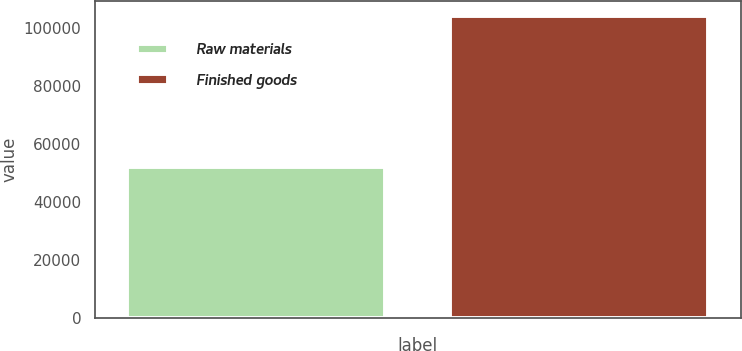Convert chart. <chart><loc_0><loc_0><loc_500><loc_500><bar_chart><fcel>Raw materials<fcel>Finished goods<nl><fcel>52043<fcel>104078<nl></chart> 